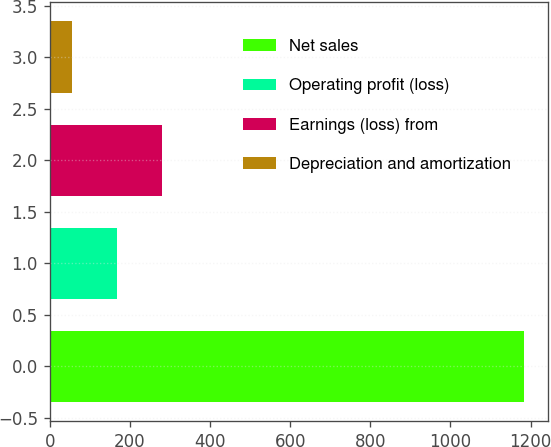Convert chart to OTSL. <chart><loc_0><loc_0><loc_500><loc_500><bar_chart><fcel>Net sales<fcel>Operating profit (loss)<fcel>Earnings (loss) from<fcel>Depreciation and amortization<nl><fcel>1184<fcel>167.9<fcel>280.8<fcel>55<nl></chart> 